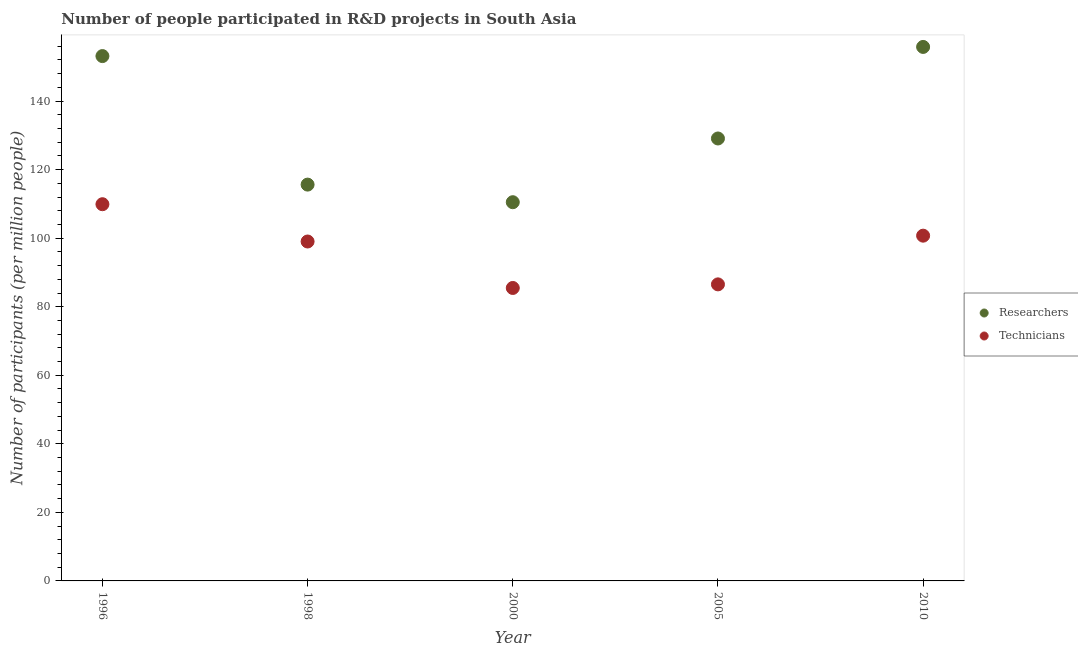Is the number of dotlines equal to the number of legend labels?
Offer a terse response. Yes. What is the number of researchers in 1996?
Ensure brevity in your answer.  153.13. Across all years, what is the maximum number of researchers?
Your answer should be compact. 155.8. Across all years, what is the minimum number of technicians?
Make the answer very short. 85.47. What is the total number of technicians in the graph?
Your answer should be compact. 481.67. What is the difference between the number of technicians in 1998 and that in 2010?
Provide a short and direct response. -1.7. What is the difference between the number of technicians in 2010 and the number of researchers in 2000?
Your response must be concise. -9.76. What is the average number of technicians per year?
Your answer should be very brief. 96.33. In the year 1996, what is the difference between the number of researchers and number of technicians?
Provide a short and direct response. 43.22. In how many years, is the number of technicians greater than 124?
Ensure brevity in your answer.  0. What is the ratio of the number of researchers in 1996 to that in 1998?
Offer a very short reply. 1.32. Is the number of technicians in 1996 less than that in 2010?
Give a very brief answer. No. Is the difference between the number of technicians in 1998 and 2010 greater than the difference between the number of researchers in 1998 and 2010?
Ensure brevity in your answer.  Yes. What is the difference between the highest and the second highest number of researchers?
Your answer should be compact. 2.67. What is the difference between the highest and the lowest number of researchers?
Offer a very short reply. 45.31. Is the sum of the number of technicians in 1996 and 2010 greater than the maximum number of researchers across all years?
Provide a short and direct response. Yes. Does the number of researchers monotonically increase over the years?
Offer a very short reply. No. How many years are there in the graph?
Offer a very short reply. 5. What is the difference between two consecutive major ticks on the Y-axis?
Your answer should be very brief. 20. Are the values on the major ticks of Y-axis written in scientific E-notation?
Offer a terse response. No. Where does the legend appear in the graph?
Offer a terse response. Center right. What is the title of the graph?
Keep it short and to the point. Number of people participated in R&D projects in South Asia. What is the label or title of the Y-axis?
Your response must be concise. Number of participants (per million people). What is the Number of participants (per million people) in Researchers in 1996?
Provide a short and direct response. 153.13. What is the Number of participants (per million people) of Technicians in 1996?
Ensure brevity in your answer.  109.91. What is the Number of participants (per million people) in Researchers in 1998?
Offer a terse response. 115.63. What is the Number of participants (per million people) of Technicians in 1998?
Offer a very short reply. 99.03. What is the Number of participants (per million people) of Researchers in 2000?
Offer a very short reply. 110.5. What is the Number of participants (per million people) of Technicians in 2000?
Offer a very short reply. 85.47. What is the Number of participants (per million people) of Researchers in 2005?
Your response must be concise. 129.09. What is the Number of participants (per million people) of Technicians in 2005?
Your answer should be very brief. 86.52. What is the Number of participants (per million people) in Researchers in 2010?
Offer a terse response. 155.8. What is the Number of participants (per million people) of Technicians in 2010?
Make the answer very short. 100.73. Across all years, what is the maximum Number of participants (per million people) of Researchers?
Your answer should be compact. 155.8. Across all years, what is the maximum Number of participants (per million people) in Technicians?
Provide a short and direct response. 109.91. Across all years, what is the minimum Number of participants (per million people) in Researchers?
Make the answer very short. 110.5. Across all years, what is the minimum Number of participants (per million people) in Technicians?
Your response must be concise. 85.47. What is the total Number of participants (per million people) of Researchers in the graph?
Your response must be concise. 664.15. What is the total Number of participants (per million people) of Technicians in the graph?
Your response must be concise. 481.67. What is the difference between the Number of participants (per million people) in Researchers in 1996 and that in 1998?
Provide a short and direct response. 37.5. What is the difference between the Number of participants (per million people) in Technicians in 1996 and that in 1998?
Make the answer very short. 10.88. What is the difference between the Number of participants (per million people) in Researchers in 1996 and that in 2000?
Offer a very short reply. 42.63. What is the difference between the Number of participants (per million people) of Technicians in 1996 and that in 2000?
Offer a terse response. 24.44. What is the difference between the Number of participants (per million people) of Researchers in 1996 and that in 2005?
Give a very brief answer. 24.04. What is the difference between the Number of participants (per million people) in Technicians in 1996 and that in 2005?
Offer a terse response. 23.39. What is the difference between the Number of participants (per million people) in Researchers in 1996 and that in 2010?
Make the answer very short. -2.67. What is the difference between the Number of participants (per million people) of Technicians in 1996 and that in 2010?
Give a very brief answer. 9.18. What is the difference between the Number of participants (per million people) of Researchers in 1998 and that in 2000?
Offer a very short reply. 5.14. What is the difference between the Number of participants (per million people) in Technicians in 1998 and that in 2000?
Offer a terse response. 13.56. What is the difference between the Number of participants (per million people) in Researchers in 1998 and that in 2005?
Ensure brevity in your answer.  -13.46. What is the difference between the Number of participants (per million people) in Technicians in 1998 and that in 2005?
Your answer should be very brief. 12.51. What is the difference between the Number of participants (per million people) in Researchers in 1998 and that in 2010?
Offer a very short reply. -40.17. What is the difference between the Number of participants (per million people) in Technicians in 1998 and that in 2010?
Your response must be concise. -1.7. What is the difference between the Number of participants (per million people) of Researchers in 2000 and that in 2005?
Provide a short and direct response. -18.59. What is the difference between the Number of participants (per million people) in Technicians in 2000 and that in 2005?
Offer a terse response. -1.05. What is the difference between the Number of participants (per million people) in Researchers in 2000 and that in 2010?
Keep it short and to the point. -45.31. What is the difference between the Number of participants (per million people) in Technicians in 2000 and that in 2010?
Provide a short and direct response. -15.26. What is the difference between the Number of participants (per million people) in Researchers in 2005 and that in 2010?
Your response must be concise. -26.71. What is the difference between the Number of participants (per million people) of Technicians in 2005 and that in 2010?
Provide a short and direct response. -14.21. What is the difference between the Number of participants (per million people) of Researchers in 1996 and the Number of participants (per million people) of Technicians in 1998?
Your response must be concise. 54.1. What is the difference between the Number of participants (per million people) in Researchers in 1996 and the Number of participants (per million people) in Technicians in 2000?
Your answer should be very brief. 67.66. What is the difference between the Number of participants (per million people) of Researchers in 1996 and the Number of participants (per million people) of Technicians in 2005?
Provide a succinct answer. 66.61. What is the difference between the Number of participants (per million people) of Researchers in 1996 and the Number of participants (per million people) of Technicians in 2010?
Your response must be concise. 52.4. What is the difference between the Number of participants (per million people) in Researchers in 1998 and the Number of participants (per million people) in Technicians in 2000?
Offer a very short reply. 30.16. What is the difference between the Number of participants (per million people) of Researchers in 1998 and the Number of participants (per million people) of Technicians in 2005?
Your response must be concise. 29.11. What is the difference between the Number of participants (per million people) of Researchers in 1998 and the Number of participants (per million people) of Technicians in 2010?
Your answer should be very brief. 14.9. What is the difference between the Number of participants (per million people) of Researchers in 2000 and the Number of participants (per million people) of Technicians in 2005?
Make the answer very short. 23.97. What is the difference between the Number of participants (per million people) of Researchers in 2000 and the Number of participants (per million people) of Technicians in 2010?
Ensure brevity in your answer.  9.76. What is the difference between the Number of participants (per million people) of Researchers in 2005 and the Number of participants (per million people) of Technicians in 2010?
Make the answer very short. 28.36. What is the average Number of participants (per million people) of Researchers per year?
Keep it short and to the point. 132.83. What is the average Number of participants (per million people) of Technicians per year?
Provide a succinct answer. 96.33. In the year 1996, what is the difference between the Number of participants (per million people) in Researchers and Number of participants (per million people) in Technicians?
Keep it short and to the point. 43.22. In the year 1998, what is the difference between the Number of participants (per million people) in Researchers and Number of participants (per million people) in Technicians?
Your answer should be very brief. 16.6. In the year 2000, what is the difference between the Number of participants (per million people) of Researchers and Number of participants (per million people) of Technicians?
Ensure brevity in your answer.  25.02. In the year 2005, what is the difference between the Number of participants (per million people) in Researchers and Number of participants (per million people) in Technicians?
Make the answer very short. 42.57. In the year 2010, what is the difference between the Number of participants (per million people) of Researchers and Number of participants (per million people) of Technicians?
Your response must be concise. 55.07. What is the ratio of the Number of participants (per million people) in Researchers in 1996 to that in 1998?
Your answer should be compact. 1.32. What is the ratio of the Number of participants (per million people) in Technicians in 1996 to that in 1998?
Ensure brevity in your answer.  1.11. What is the ratio of the Number of participants (per million people) of Researchers in 1996 to that in 2000?
Make the answer very short. 1.39. What is the ratio of the Number of participants (per million people) of Technicians in 1996 to that in 2000?
Your answer should be compact. 1.29. What is the ratio of the Number of participants (per million people) in Researchers in 1996 to that in 2005?
Offer a very short reply. 1.19. What is the ratio of the Number of participants (per million people) of Technicians in 1996 to that in 2005?
Offer a terse response. 1.27. What is the ratio of the Number of participants (per million people) of Researchers in 1996 to that in 2010?
Keep it short and to the point. 0.98. What is the ratio of the Number of participants (per million people) in Technicians in 1996 to that in 2010?
Your answer should be compact. 1.09. What is the ratio of the Number of participants (per million people) of Researchers in 1998 to that in 2000?
Provide a succinct answer. 1.05. What is the ratio of the Number of participants (per million people) of Technicians in 1998 to that in 2000?
Offer a terse response. 1.16. What is the ratio of the Number of participants (per million people) of Researchers in 1998 to that in 2005?
Make the answer very short. 0.9. What is the ratio of the Number of participants (per million people) in Technicians in 1998 to that in 2005?
Offer a very short reply. 1.14. What is the ratio of the Number of participants (per million people) of Researchers in 1998 to that in 2010?
Your answer should be very brief. 0.74. What is the ratio of the Number of participants (per million people) of Technicians in 1998 to that in 2010?
Offer a very short reply. 0.98. What is the ratio of the Number of participants (per million people) in Researchers in 2000 to that in 2005?
Provide a succinct answer. 0.86. What is the ratio of the Number of participants (per million people) of Technicians in 2000 to that in 2005?
Your response must be concise. 0.99. What is the ratio of the Number of participants (per million people) of Researchers in 2000 to that in 2010?
Provide a succinct answer. 0.71. What is the ratio of the Number of participants (per million people) of Technicians in 2000 to that in 2010?
Ensure brevity in your answer.  0.85. What is the ratio of the Number of participants (per million people) of Researchers in 2005 to that in 2010?
Make the answer very short. 0.83. What is the ratio of the Number of participants (per million people) of Technicians in 2005 to that in 2010?
Ensure brevity in your answer.  0.86. What is the difference between the highest and the second highest Number of participants (per million people) of Researchers?
Provide a succinct answer. 2.67. What is the difference between the highest and the second highest Number of participants (per million people) in Technicians?
Give a very brief answer. 9.18. What is the difference between the highest and the lowest Number of participants (per million people) in Researchers?
Offer a terse response. 45.31. What is the difference between the highest and the lowest Number of participants (per million people) of Technicians?
Your answer should be compact. 24.44. 